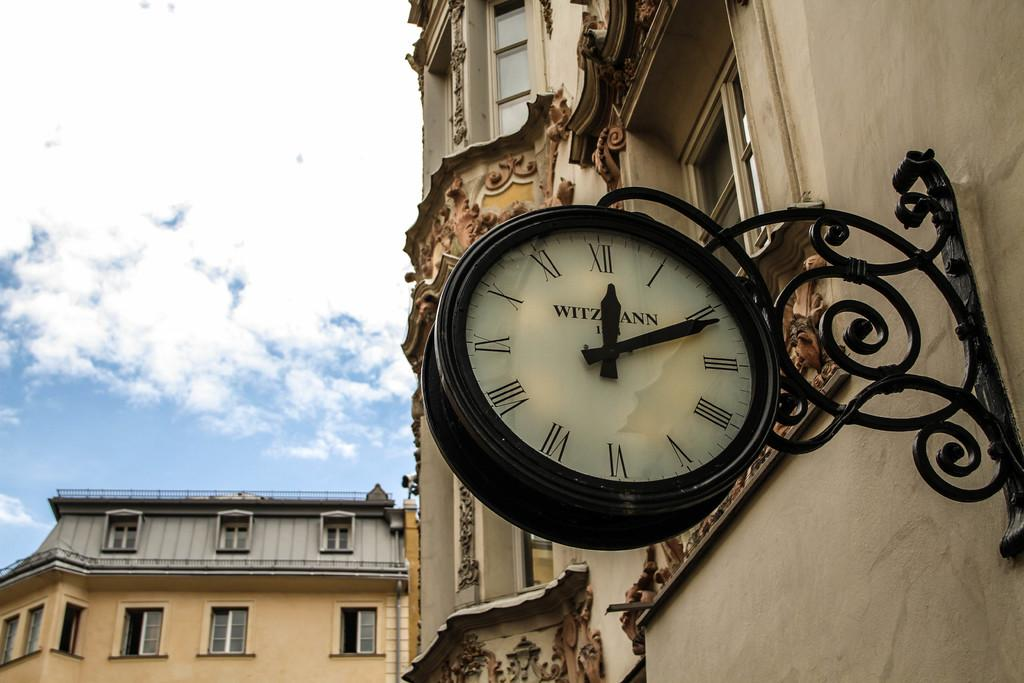What object in the image can be used to tell time? There is a wall clock in the image that can be used to tell time. What type of structures are visible in the image? There are buildings in the image. What is visible at the top of the image? The sky is visible at the top of the image. Can you see a baby playing with a watch in the image? There is no baby or watch present in the image. Is there any writing visible on the buildings in the image? The provided facts do not mention any writing on the buildings, so we cannot determine if there is any writing visible. 